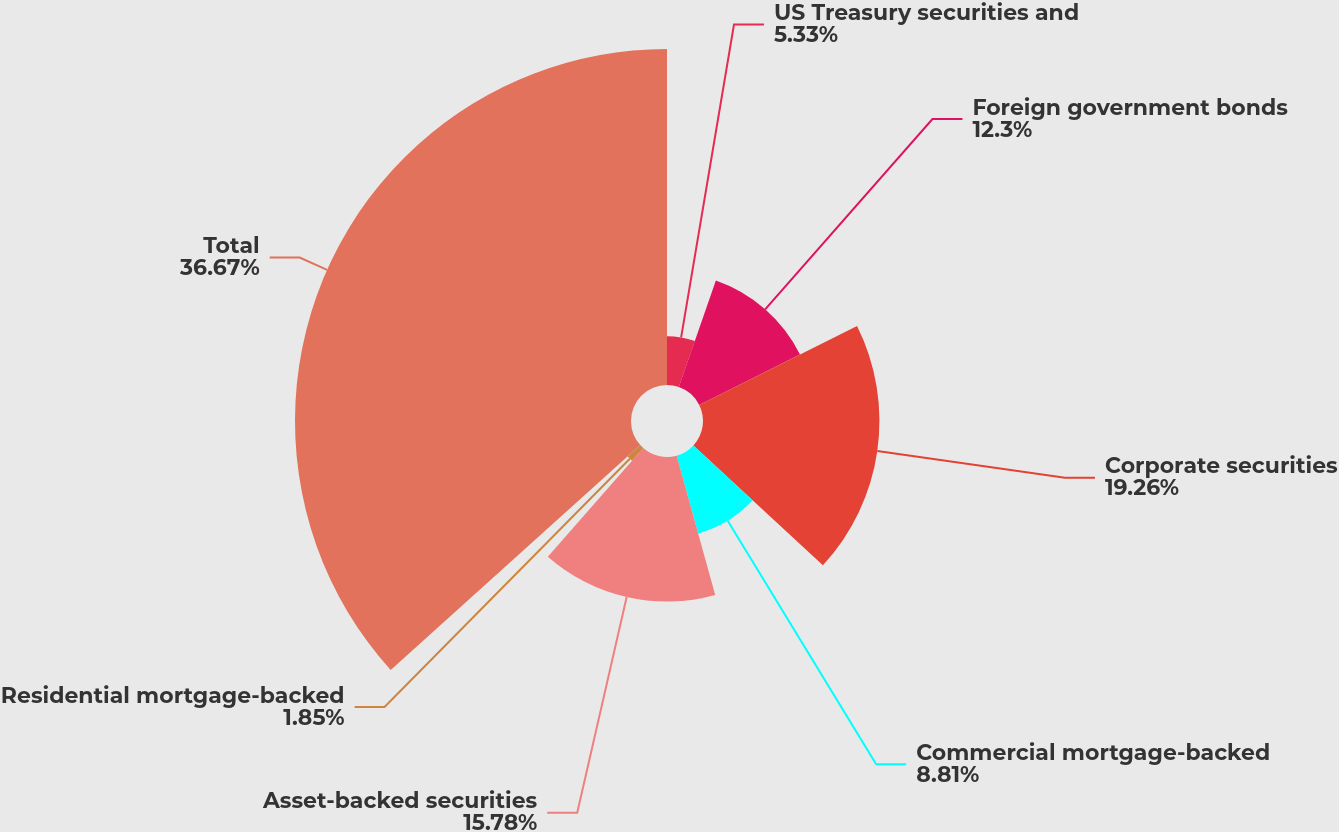Convert chart. <chart><loc_0><loc_0><loc_500><loc_500><pie_chart><fcel>US Treasury securities and<fcel>Foreign government bonds<fcel>Corporate securities<fcel>Commercial mortgage-backed<fcel>Asset-backed securities<fcel>Residential mortgage-backed<fcel>Total<nl><fcel>5.33%<fcel>12.3%<fcel>19.26%<fcel>8.81%<fcel>15.78%<fcel>1.85%<fcel>36.68%<nl></chart> 